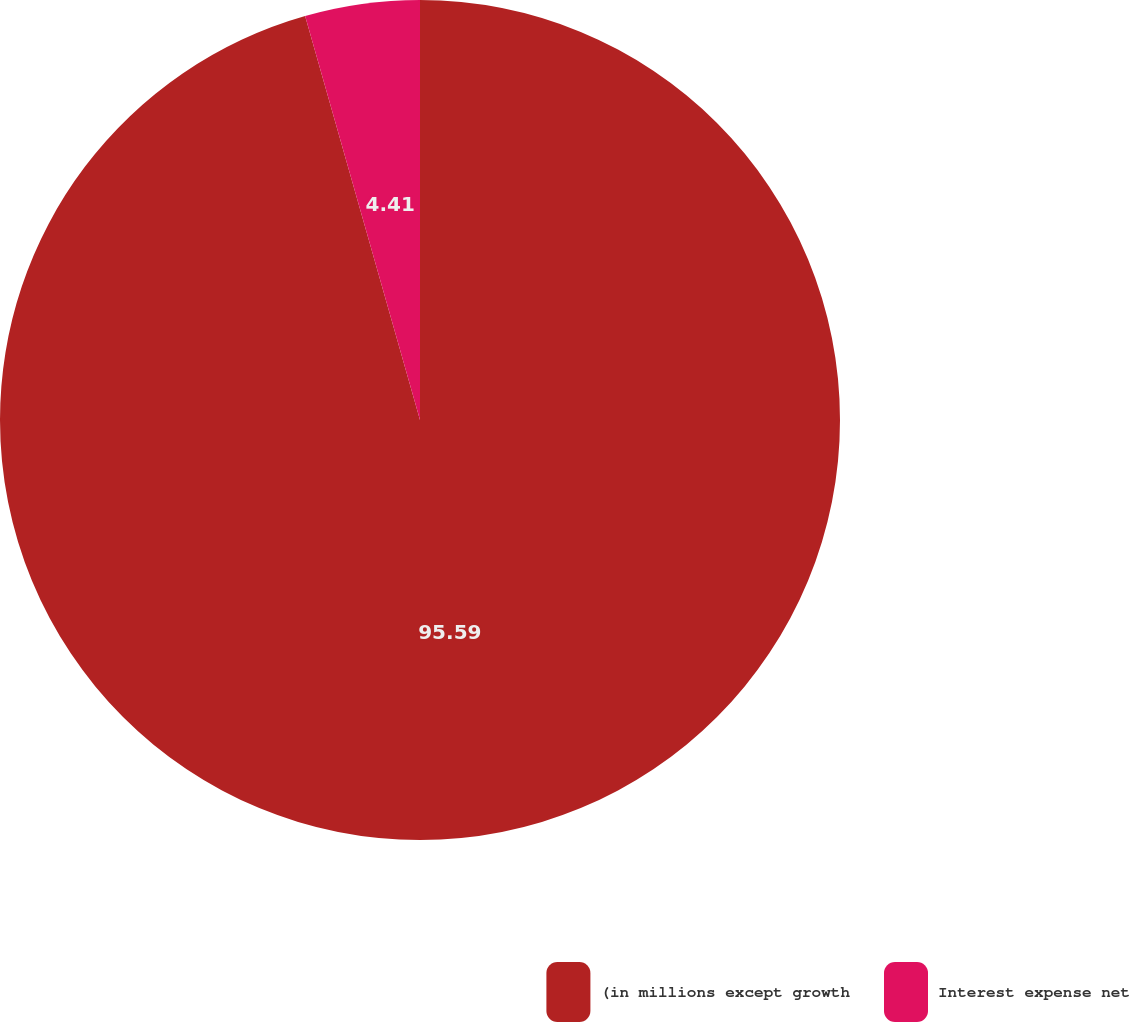<chart> <loc_0><loc_0><loc_500><loc_500><pie_chart><fcel>(in millions except growth<fcel>Interest expense net<nl><fcel>95.59%<fcel>4.41%<nl></chart> 